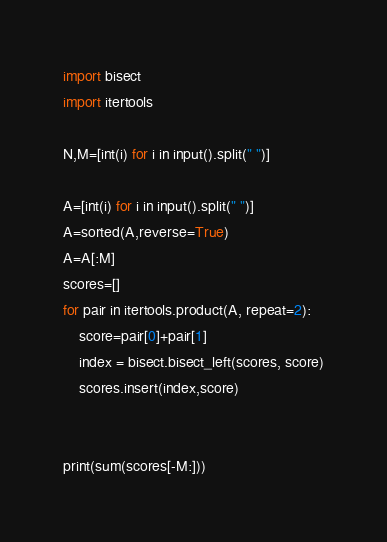<code> <loc_0><loc_0><loc_500><loc_500><_Python_>import bisect
import itertools

N,M=[int(i) for i in input().split(" ")]

A=[int(i) for i in input().split(" ")]
A=sorted(A,reverse=True)
A=A[:M]
scores=[]
for pair in itertools.product(A, repeat=2):
    score=pair[0]+pair[1]
    index = bisect.bisect_left(scores, score)
    scores.insert(index,score)


print(sum(scores[-M:]))
</code> 